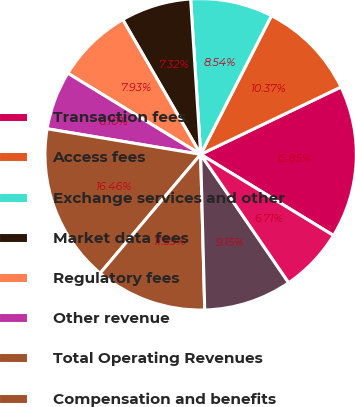<chart> <loc_0><loc_0><loc_500><loc_500><pie_chart><fcel>Transaction fees<fcel>Access fees<fcel>Exchange services and other<fcel>Market data fees<fcel>Regulatory fees<fcel>Other revenue<fcel>Total Operating Revenues<fcel>Compensation and benefits<fcel>Depreciation and amortization<fcel>Technology support services<nl><fcel>15.85%<fcel>10.37%<fcel>8.54%<fcel>7.32%<fcel>7.93%<fcel>6.1%<fcel>16.46%<fcel>11.59%<fcel>9.15%<fcel>6.71%<nl></chart> 